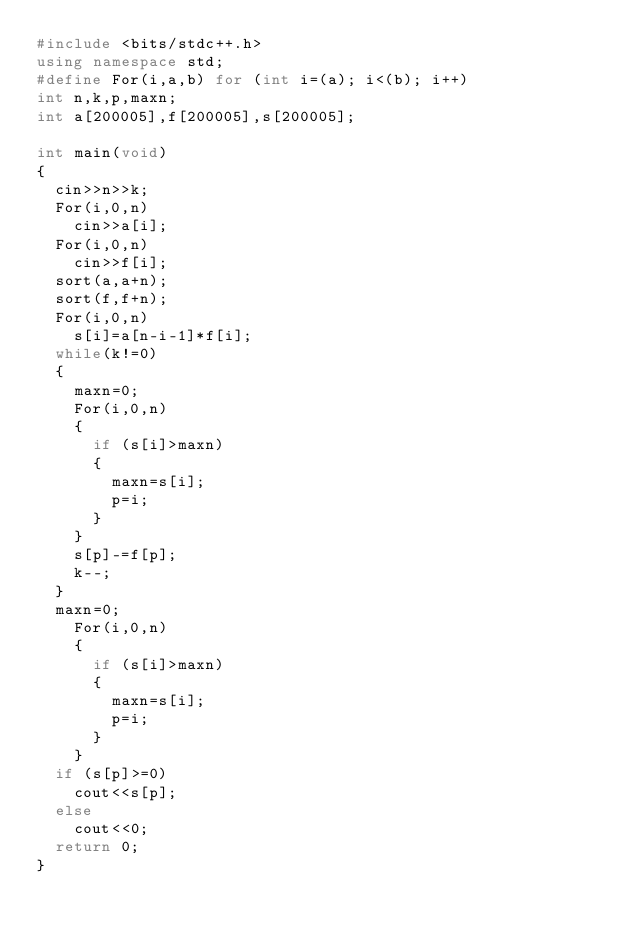Convert code to text. <code><loc_0><loc_0><loc_500><loc_500><_C++_>#include <bits/stdc++.h>
using namespace std;
#define For(i,a,b) for (int i=(a); i<(b); i++)
int n,k,p,maxn;
int a[200005],f[200005],s[200005];

int main(void)
{
	cin>>n>>k;
	For(i,0,n)
		cin>>a[i];
	For(i,0,n)
		cin>>f[i];
	sort(a,a+n);
	sort(f,f+n);
	For(i,0,n)
		s[i]=a[n-i-1]*f[i];
	while(k!=0)
	{
		maxn=0;
		For(i,0,n)
		{
			if (s[i]>maxn)
			{
				maxn=s[i];
				p=i;
			}
		}
		s[p]-=f[p];
		k--;
	}
	maxn=0;
		For(i,0,n)
		{
			if (s[i]>maxn)
			{
				maxn=s[i];
				p=i;
			}
		}
	if (s[p]>=0)
		cout<<s[p];
	else
		cout<<0;
	return 0;
}</code> 